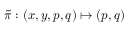<formula> <loc_0><loc_0><loc_500><loc_500>\tilde { \pi } \colon ( x , y , p , q ) \mapsto ( p , q )</formula> 